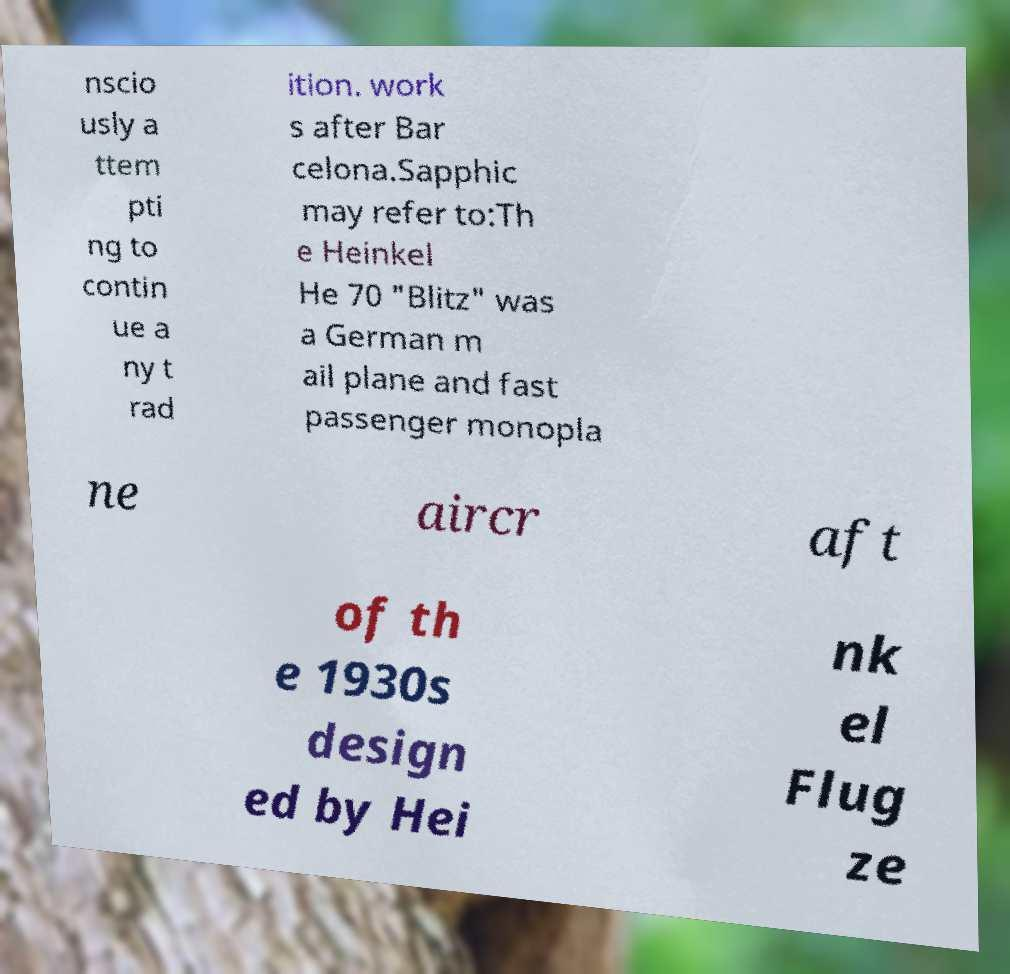Could you extract and type out the text from this image? nscio usly a ttem pti ng to contin ue a ny t rad ition. work s after Bar celona.Sapphic may refer to:Th e Heinkel He 70 "Blitz" was a German m ail plane and fast passenger monopla ne aircr aft of th e 1930s design ed by Hei nk el Flug ze 